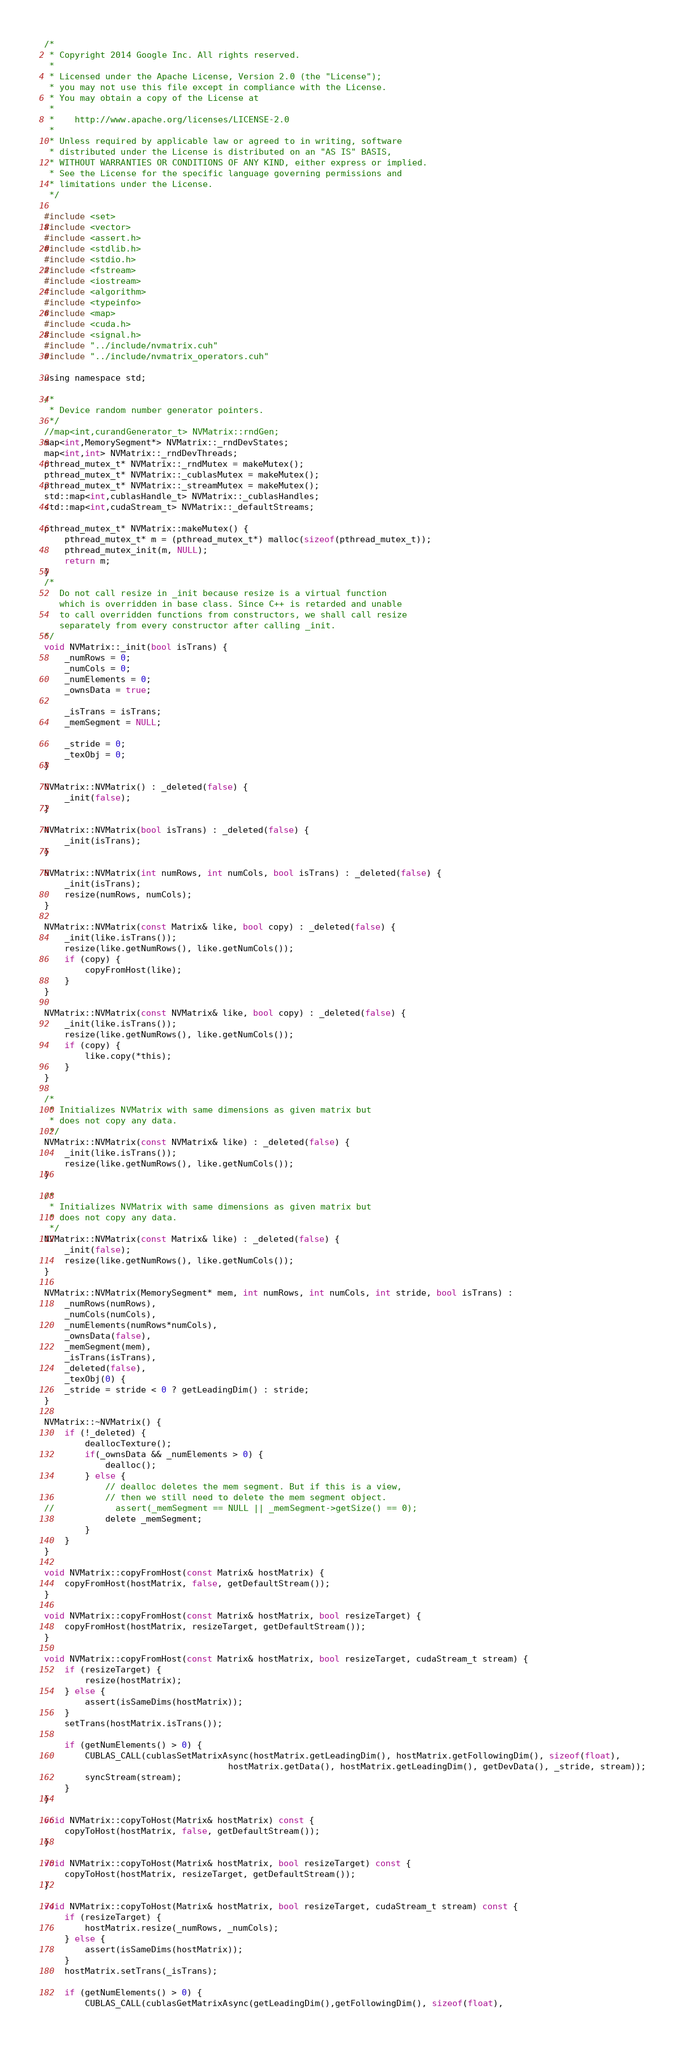Convert code to text. <code><loc_0><loc_0><loc_500><loc_500><_Cuda_>/*
 * Copyright 2014 Google Inc. All rights reserved.
 *
 * Licensed under the Apache License, Version 2.0 (the "License");
 * you may not use this file except in compliance with the License.
 * You may obtain a copy of the License at
 *
 *    http://www.apache.org/licenses/LICENSE-2.0
 *
 * Unless required by applicable law or agreed to in writing, software
 * distributed under the License is distributed on an "AS IS" BASIS,
 * WITHOUT WARRANTIES OR CONDITIONS OF ANY KIND, either express or implied.
 * See the License for the specific language governing permissions and
 * limitations under the License.
 */

#include <set>
#include <vector>
#include <assert.h>
#include <stdlib.h>
#include <stdio.h>
#include <fstream>
#include <iostream>
#include <algorithm>
#include <typeinfo>
#include <map>
#include <cuda.h>
#include <signal.h>
#include "../include/nvmatrix.cuh"
#include "../include/nvmatrix_operators.cuh"

using namespace std;

/*
 * Device random number generator pointers.
 */
//map<int,curandGenerator_t> NVMatrix::rndGen;
map<int,MemorySegment*> NVMatrix::_rndDevStates;
map<int,int> NVMatrix::_rndDevThreads;
pthread_mutex_t* NVMatrix::_rndMutex = makeMutex();
pthread_mutex_t* NVMatrix::_cublasMutex = makeMutex();
pthread_mutex_t* NVMatrix::_streamMutex = makeMutex();
std::map<int,cublasHandle_t> NVMatrix::_cublasHandles;
std::map<int,cudaStream_t> NVMatrix::_defaultStreams;

pthread_mutex_t* NVMatrix::makeMutex() {
    pthread_mutex_t* m = (pthread_mutex_t*) malloc(sizeof(pthread_mutex_t));
    pthread_mutex_init(m, NULL);
    return m;
}
/*
   Do not call resize in _init because resize is a virtual function
   which is overridden in base class. Since C++ is retarded and unable
   to call overridden functions from constructors, we shall call resize
   separately from every constructor after calling _init.
*/
void NVMatrix::_init(bool isTrans) {
    _numRows = 0;
    _numCols = 0;
    _numElements = 0;
    _ownsData = true;

    _isTrans = isTrans;
    _memSegment = NULL;

    _stride = 0;
    _texObj = 0;
}

NVMatrix::NVMatrix() : _deleted(false) {
    _init(false);
}

NVMatrix::NVMatrix(bool isTrans) : _deleted(false) {
    _init(isTrans);
}

NVMatrix::NVMatrix(int numRows, int numCols, bool isTrans) : _deleted(false) {
    _init(isTrans);
    resize(numRows, numCols);
}

NVMatrix::NVMatrix(const Matrix& like, bool copy) : _deleted(false) {
    _init(like.isTrans());
    resize(like.getNumRows(), like.getNumCols());
    if (copy) {
        copyFromHost(like);
    }
}

NVMatrix::NVMatrix(const NVMatrix& like, bool copy) : _deleted(false) {
    _init(like.isTrans());
    resize(like.getNumRows(), like.getNumCols());
    if (copy) {
        like.copy(*this);
    }
}

/*
 * Initializes NVMatrix with same dimensions as given matrix but
 * does not copy any data.
 */
NVMatrix::NVMatrix(const NVMatrix& like) : _deleted(false) {
    _init(like.isTrans());
    resize(like.getNumRows(), like.getNumCols());
}

/*
 * Initializes NVMatrix with same dimensions as given matrix but
 * does not copy any data.
 */
NVMatrix::NVMatrix(const Matrix& like) : _deleted(false) {
    _init(false);
    resize(like.getNumRows(), like.getNumCols());
}

NVMatrix::NVMatrix(MemorySegment* mem, int numRows, int numCols, int stride, bool isTrans) :
    _numRows(numRows),
    _numCols(numCols),
    _numElements(numRows*numCols),
    _ownsData(false),
    _memSegment(mem),
    _isTrans(isTrans),
    _deleted(false),
    _texObj(0) {
    _stride = stride < 0 ? getLeadingDim() : stride;
}

NVMatrix::~NVMatrix() {
    if (!_deleted) {
        deallocTexture();
        if(_ownsData && _numElements > 0) {
            dealloc();
        } else {
            // dealloc deletes the mem segment. But if this is a view,
            // then we still need to delete the mem segment object.
//            assert(_memSegment == NULL || _memSegment->getSize() == 0);
            delete _memSegment;
        }
    }
}

void NVMatrix::copyFromHost(const Matrix& hostMatrix) {
    copyFromHost(hostMatrix, false, getDefaultStream());
}

void NVMatrix::copyFromHost(const Matrix& hostMatrix, bool resizeTarget) {
    copyFromHost(hostMatrix, resizeTarget, getDefaultStream());
}

void NVMatrix::copyFromHost(const Matrix& hostMatrix, bool resizeTarget, cudaStream_t stream) {
    if (resizeTarget) {
        resize(hostMatrix);
    } else {
        assert(isSameDims(hostMatrix));
    }
    setTrans(hostMatrix.isTrans());

    if (getNumElements() > 0) {
        CUBLAS_CALL(cublasSetMatrixAsync(hostMatrix.getLeadingDim(), hostMatrix.getFollowingDim(), sizeof(float),
                                    hostMatrix.getData(), hostMatrix.getLeadingDim(), getDevData(), _stride, stream));
        syncStream(stream);
    }
}

void NVMatrix::copyToHost(Matrix& hostMatrix) const {
    copyToHost(hostMatrix, false, getDefaultStream());
}

void NVMatrix::copyToHost(Matrix& hostMatrix, bool resizeTarget) const {
    copyToHost(hostMatrix, resizeTarget, getDefaultStream());
}

void NVMatrix::copyToHost(Matrix& hostMatrix, bool resizeTarget, cudaStream_t stream) const {
    if (resizeTarget) {
        hostMatrix.resize(_numRows, _numCols);
    } else {
        assert(isSameDims(hostMatrix));
    }
    hostMatrix.setTrans(_isTrans);

    if (getNumElements() > 0) {
        CUBLAS_CALL(cublasGetMatrixAsync(getLeadingDim(),getFollowingDim(), sizeof(float),</code> 